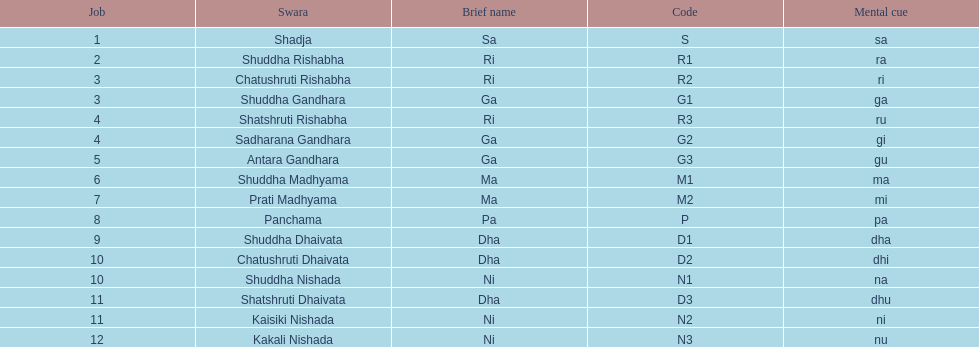What is the name of the swara that holds the first position? Shadja. 